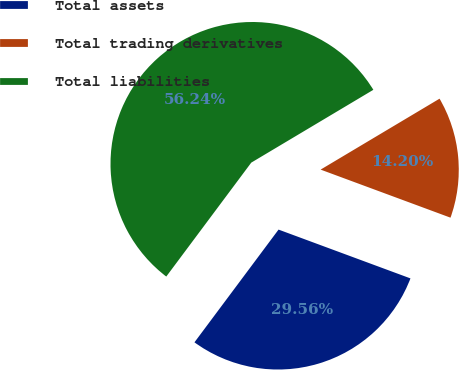Convert chart. <chart><loc_0><loc_0><loc_500><loc_500><pie_chart><fcel>Total assets<fcel>Total trading derivatives<fcel>Total liabilities<nl><fcel>29.56%<fcel>14.2%<fcel>56.24%<nl></chart> 